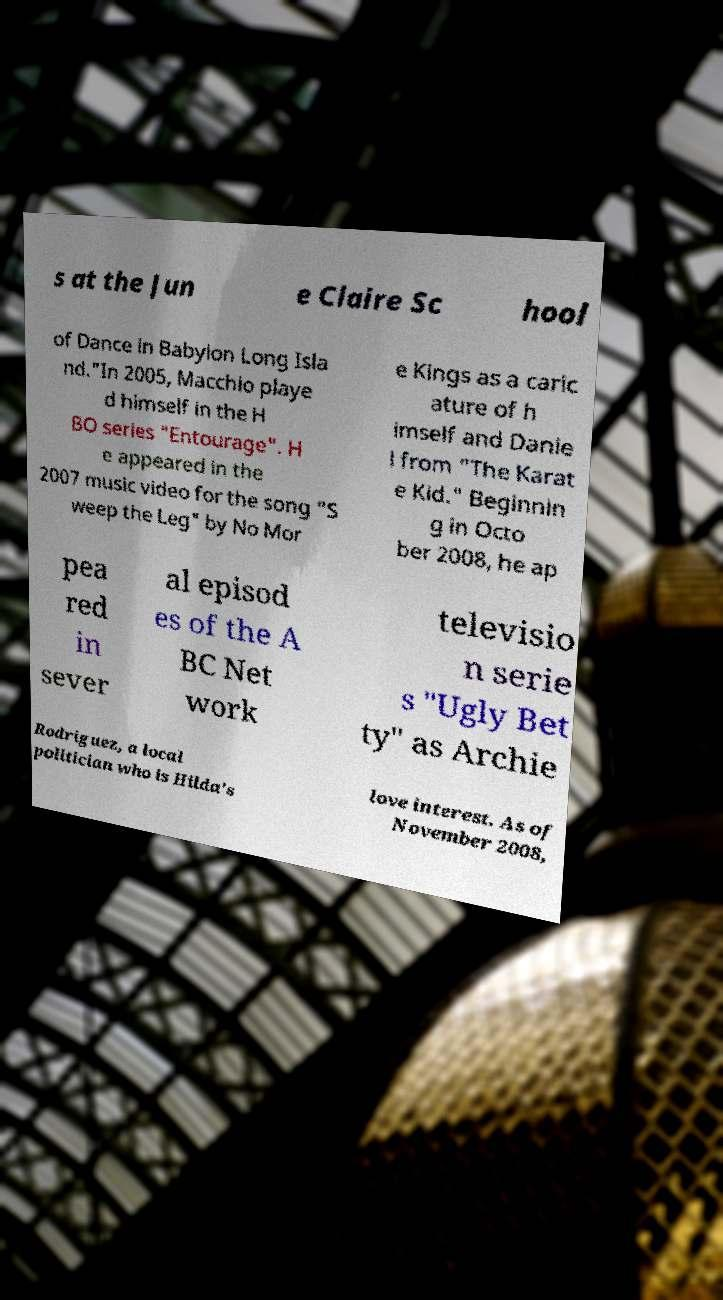Can you read and provide the text displayed in the image?This photo seems to have some interesting text. Can you extract and type it out for me? s at the Jun e Claire Sc hool of Dance in Babylon Long Isla nd."In 2005, Macchio playe d himself in the H BO series "Entourage". H e appeared in the 2007 music video for the song "S weep the Leg" by No Mor e Kings as a caric ature of h imself and Danie l from "The Karat e Kid." Beginnin g in Octo ber 2008, he ap pea red in sever al episod es of the A BC Net work televisio n serie s "Ugly Bet ty" as Archie Rodriguez, a local politician who is Hilda's love interest. As of November 2008, 